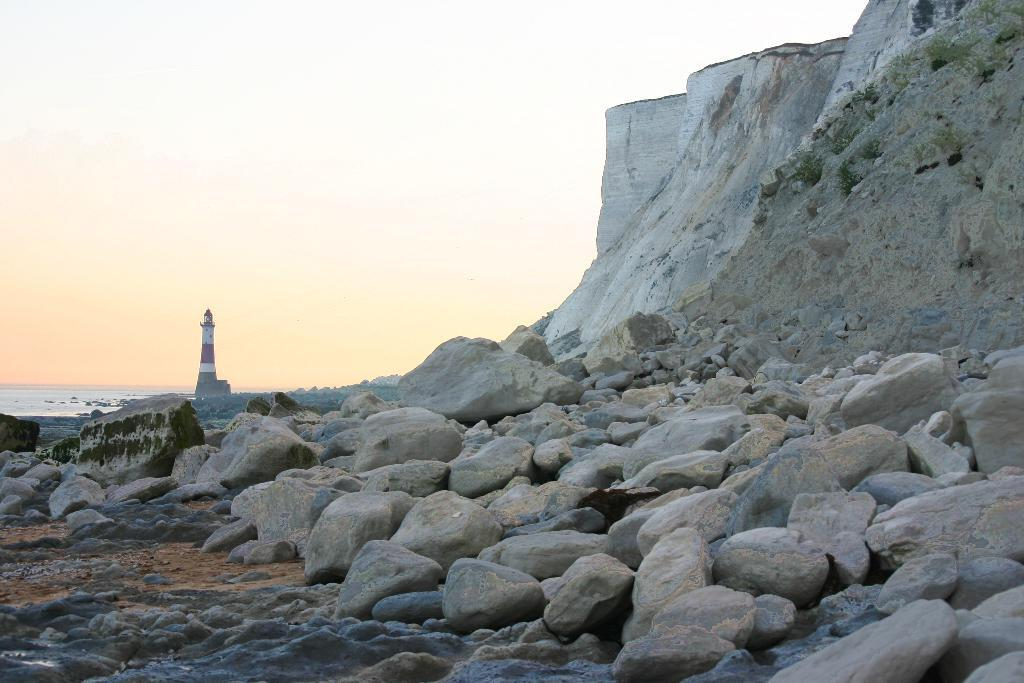What type of natural formation can be seen in the image? There are rocks in the image. What structure is visible in the background of the image? There is a tower in the background of the image. What body of water is present in the image? There is water visible in the image, which appears to be an ocean. What is visible at the top of the image? The sky is visible at the top of the image. What color is the orange in the image? There is no orange present in the image. What time of day is it in the image, given that it is morning? The time of day cannot be determined from the image, and there is no mention of morning in the provided facts. 